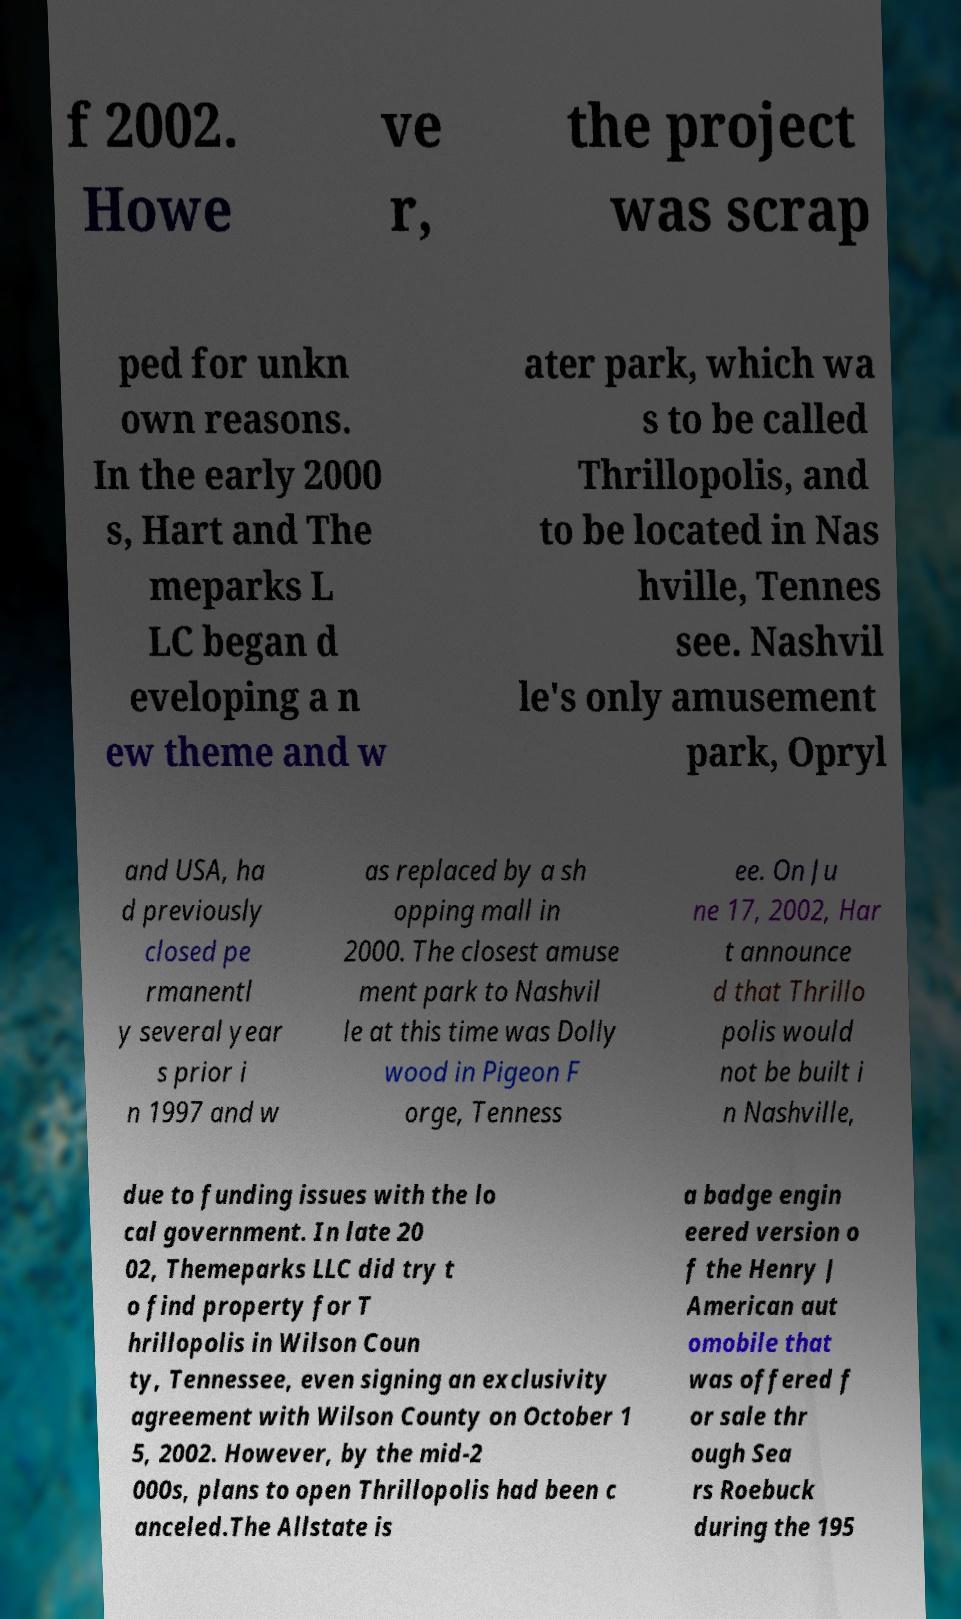Please identify and transcribe the text found in this image. f 2002. Howe ve r, the project was scrap ped for unkn own reasons. In the early 2000 s, Hart and The meparks L LC began d eveloping a n ew theme and w ater park, which wa s to be called Thrillopolis, and to be located in Nas hville, Tennes see. Nashvil le's only amusement park, Opryl and USA, ha d previously closed pe rmanentl y several year s prior i n 1997 and w as replaced by a sh opping mall in 2000. The closest amuse ment park to Nashvil le at this time was Dolly wood in Pigeon F orge, Tenness ee. On Ju ne 17, 2002, Har t announce d that Thrillo polis would not be built i n Nashville, due to funding issues with the lo cal government. In late 20 02, Themeparks LLC did try t o find property for T hrillopolis in Wilson Coun ty, Tennessee, even signing an exclusivity agreement with Wilson County on October 1 5, 2002. However, by the mid-2 000s, plans to open Thrillopolis had been c anceled.The Allstate is a badge engin eered version o f the Henry J American aut omobile that was offered f or sale thr ough Sea rs Roebuck during the 195 